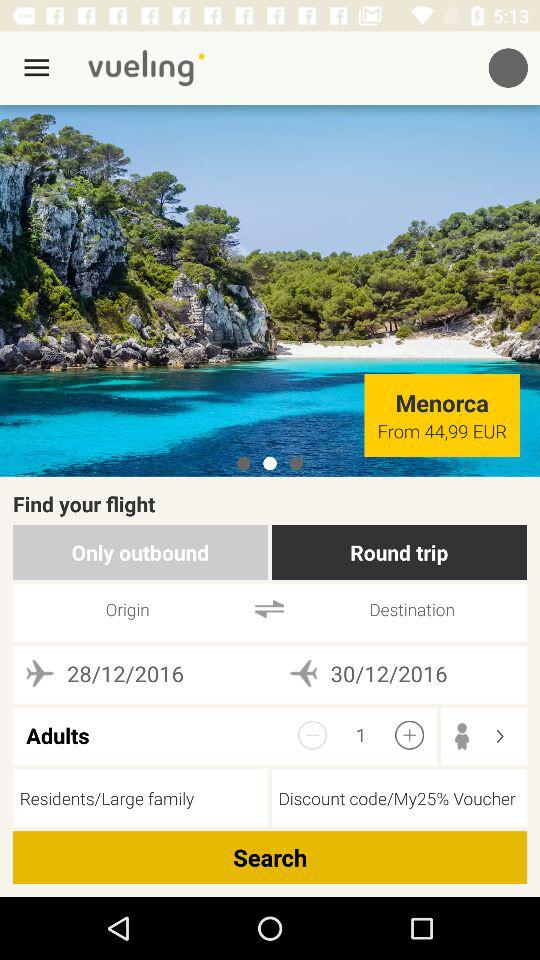What is the type of trip? The type of trip is round. 